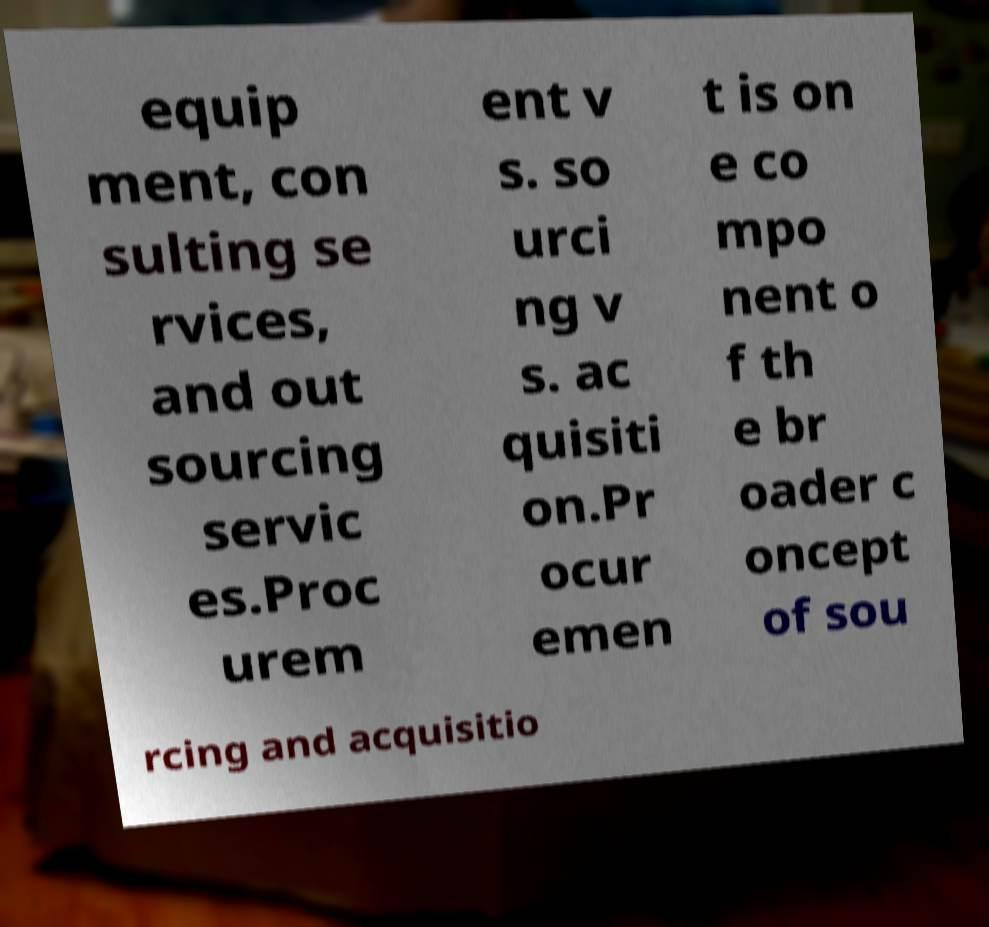Can you read and provide the text displayed in the image?This photo seems to have some interesting text. Can you extract and type it out for me? equip ment, con sulting se rvices, and out sourcing servic es.Proc urem ent v s. so urci ng v s. ac quisiti on.Pr ocur emen t is on e co mpo nent o f th e br oader c oncept of sou rcing and acquisitio 